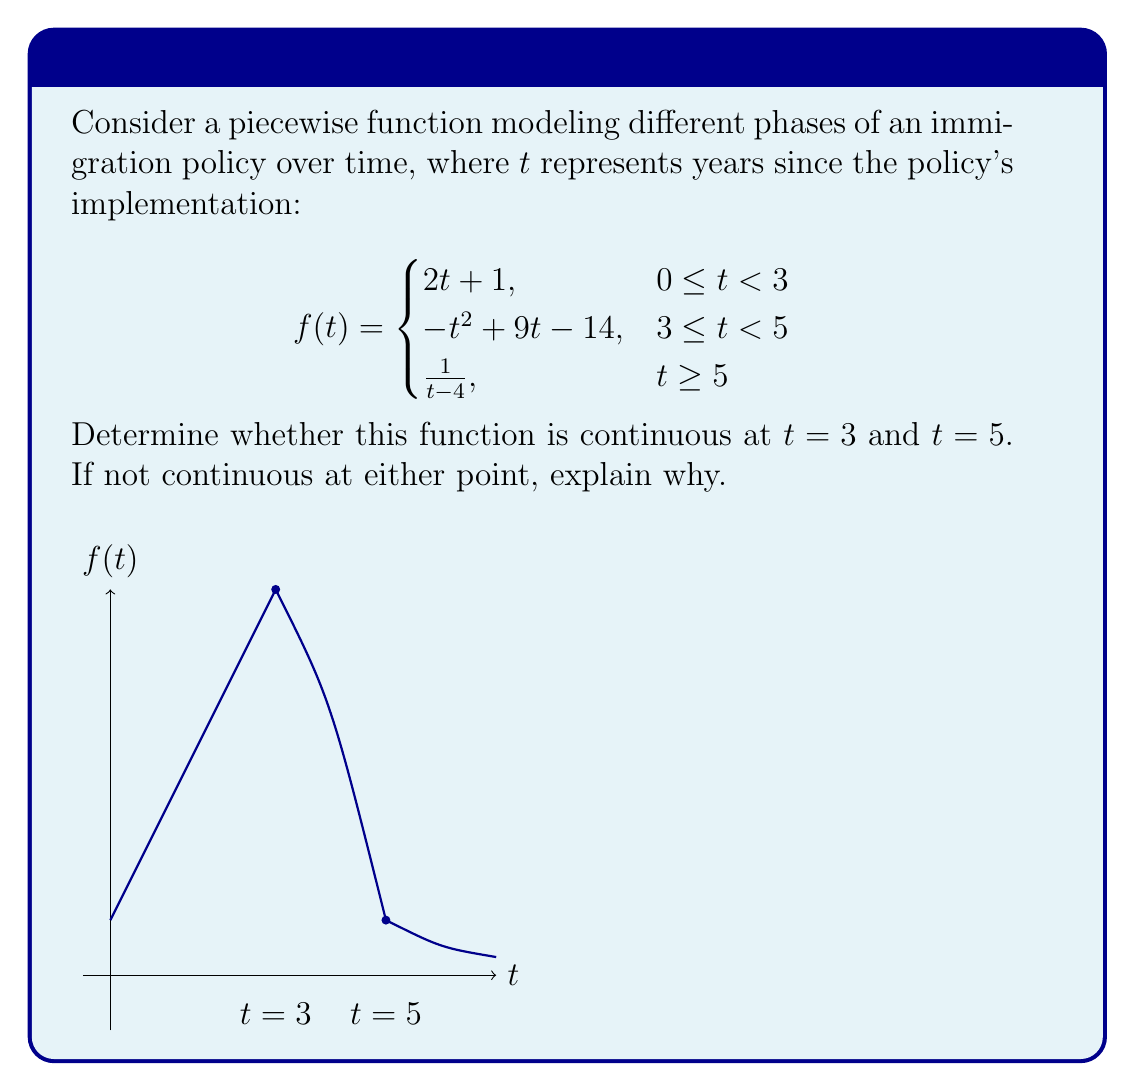Could you help me with this problem? To determine continuity at $t = 3$ and $t = 5$, we need to check three conditions at each point:
1. The function is defined at the point
2. The limit of the function as we approach the point from both sides exists
3. The limit equals the function value at that point

For $t = 3$:

1. $f(3)$ is defined: $f(3) = -3^2 + 9(3) - 14 = -9 + 27 - 14 = 4$
2. Left-hand limit: 
   $\lim_{t \to 3^-} f(t) = \lim_{t \to 3^-} (2t + 1) = 2(3) + 1 = 7$
   Right-hand limit:
   $\lim_{t \to 3^+} f(t) = \lim_{t \to 3^+} (-t^2 + 9t - 14) = -(3^2) + 9(3) - 14 = 4$
3. $\lim_{t \to 3^-} f(t) \neq \lim_{t \to 3^+} f(t) \neq f(3)$

Therefore, $f(t)$ is not continuous at $t = 3$ due to a jump discontinuity.

For $t = 5$:

1. $f(5)$ is defined: $f(5) = \frac{1}{5-4} = 1$
2. Left-hand limit:
   $\lim_{t \to 5^-} f(t) = \lim_{t \to 5^-} (-t^2 + 9t - 14) = -(5^2) + 9(5) - 14 = 1$
   Right-hand limit:
   $\lim_{t \to 5^+} f(t) = \lim_{t \to 5^+} \frac{1}{t-4} = \frac{1}{5-4} = 1$
3. $\lim_{t \to 5^-} f(t) = \lim_{t \to 5^+} f(t) = f(5) = 1$

Therefore, $f(t)$ is continuous at $t = 5$.
Answer: The function is discontinuous at $t = 3$ but continuous at $t = 5$. 